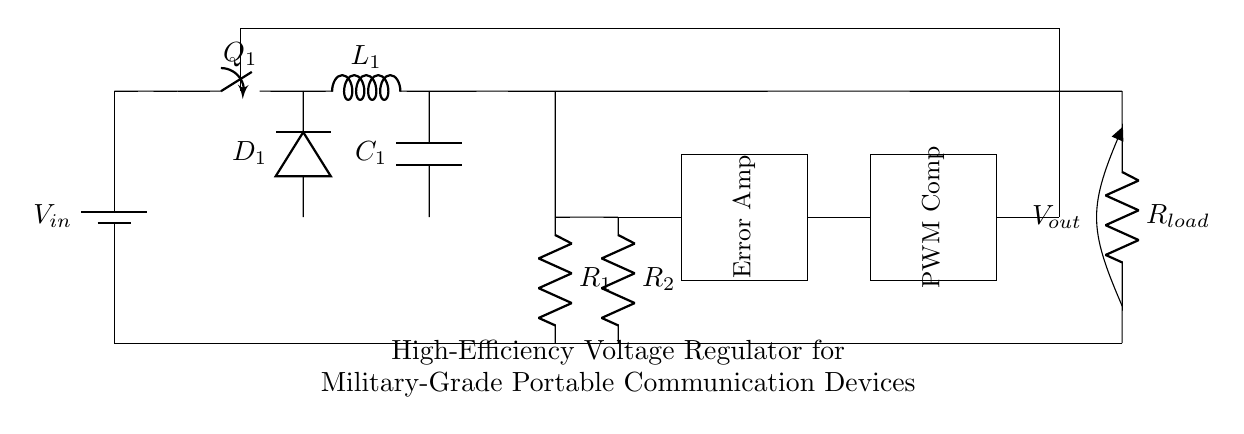What is the input voltage in this circuit? The circuit diagram shows a battery as the input source labeled with \( V_{in} \). However, the exact voltage value isn't specified in the diagram.
Answer: \( V_{in} \) What type of switch is used in this circuit? The switch is labeled as \( Q_1 \), which commonly indicates a transistor or a MOSFET in a buck converter application. The specific symbol used denotes it is appropriate for high-frequency switching.
Answer: Transistor How many resistors are present in the feedback section? There are two resistors labeled \( R_1 \) and \( R_2 \) in the feedback section of the circuit. They form a voltage divider for feedback purposes.
Answer: 2 What is the role of the error amplifier in this circuit? The error amplifier processes the feedback voltage and compares it to a reference voltage to adjust the PWM signal controlling the switch \( Q_1 \). This regulation helps maintain the desired output voltage despite variations in input or load.
Answer: Regulation What is the function of the PWM comparator? The PWM comparator compares the output of the error amplifier with a triangular or sawtooth waveform to generate a PWM signal. This signal controls the duty cycle of the switching element \( Q_1 \), thereby regulating the output voltage.
Answer: Generate PWM signal What is the output voltage represented by? The output voltage is represented by \( V_{out} \) and is taken across the load resistor \( R_{load} \). This provides the regulated voltage to the connected communication device.
Answer: \( V_{out} \) 